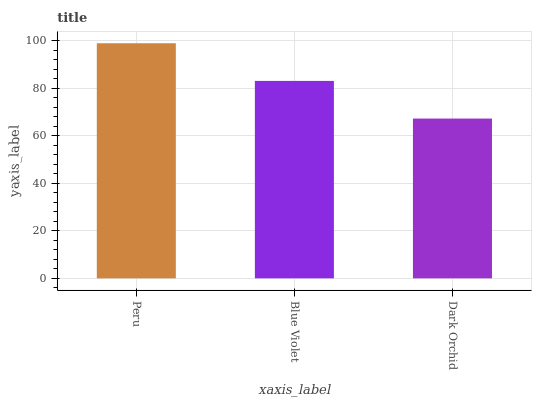Is Dark Orchid the minimum?
Answer yes or no. Yes. Is Peru the maximum?
Answer yes or no. Yes. Is Blue Violet the minimum?
Answer yes or no. No. Is Blue Violet the maximum?
Answer yes or no. No. Is Peru greater than Blue Violet?
Answer yes or no. Yes. Is Blue Violet less than Peru?
Answer yes or no. Yes. Is Blue Violet greater than Peru?
Answer yes or no. No. Is Peru less than Blue Violet?
Answer yes or no. No. Is Blue Violet the high median?
Answer yes or no. Yes. Is Blue Violet the low median?
Answer yes or no. Yes. Is Dark Orchid the high median?
Answer yes or no. No. Is Dark Orchid the low median?
Answer yes or no. No. 